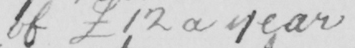Please transcribe the handwritten text in this image. of  £12 a year 